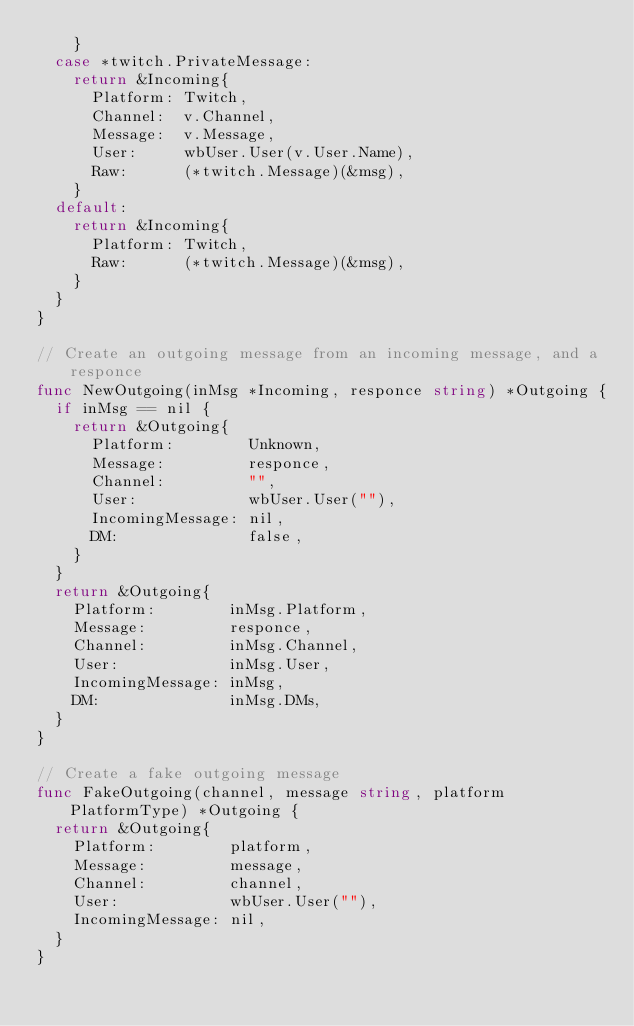<code> <loc_0><loc_0><loc_500><loc_500><_Go_>		}
	case *twitch.PrivateMessage:
		return &Incoming{
			Platform: Twitch,
			Channel:  v.Channel,
			Message:  v.Message,
			User:     wbUser.User(v.User.Name),
			Raw:      (*twitch.Message)(&msg),
		}
	default:
		return &Incoming{
			Platform: Twitch,
			Raw:      (*twitch.Message)(&msg),
		}
	}
}

// Create an outgoing message from an incoming message, and a responce
func NewOutgoing(inMsg *Incoming, responce string) *Outgoing {
	if inMsg == nil {
		return &Outgoing{
			Platform:        Unknown,
			Message:         responce,
			Channel:         "",
			User:            wbUser.User(""),
			IncomingMessage: nil,
			DM:              false,
		}
	}
	return &Outgoing{
		Platform:        inMsg.Platform,
		Message:         responce,
		Channel:         inMsg.Channel,
		User:            inMsg.User,
		IncomingMessage: inMsg,
		DM:              inMsg.DMs,
	}
}

// Create a fake outgoing message
func FakeOutgoing(channel, message string, platform PlatformType) *Outgoing {
	return &Outgoing{
		Platform:        platform,
		Message:         message,
		Channel:         channel,
		User:            wbUser.User(""),
		IncomingMessage: nil,
	}
}
</code> 